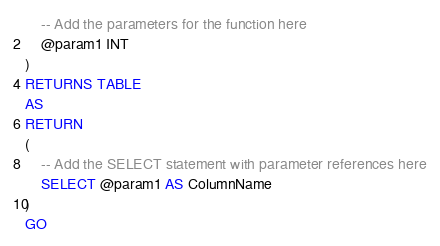<code> <loc_0><loc_0><loc_500><loc_500><_SQL_>	-- Add the parameters for the function here
	@param1 INT
)
RETURNS TABLE 
AS
RETURN 
(
	-- Add the SELECT statement with parameter references here
	SELECT @param1 AS ColumnName
)
GO
</code> 